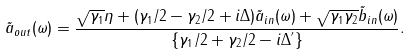Convert formula to latex. <formula><loc_0><loc_0><loc_500><loc_500>\tilde { a } _ { o u t } ( \omega ) = \frac { \sqrt { \gamma _ { 1 } } \eta + ( \gamma _ { 1 } / 2 - \gamma _ { 2 } / 2 + i \Delta ) \tilde { a } _ { i n } ( \omega ) + \sqrt { \gamma _ { 1 } \gamma _ { 2 } } \tilde { b } _ { i n } ( \omega ) } { \left \{ \gamma _ { 1 } / 2 + \gamma _ { 2 } / 2 - i \Delta ^ { ^ { \prime } } \right \} } .</formula> 